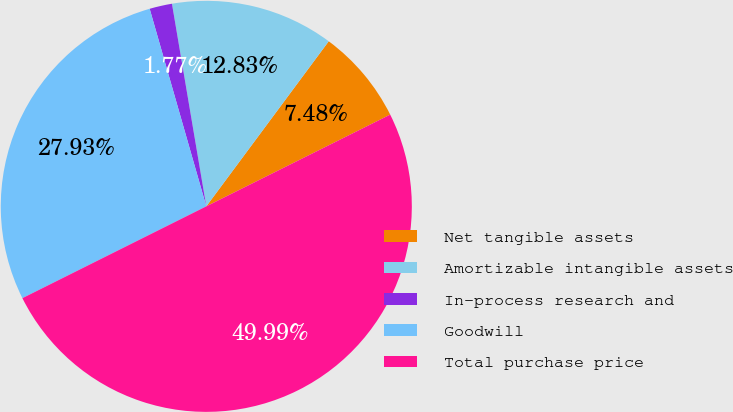Convert chart to OTSL. <chart><loc_0><loc_0><loc_500><loc_500><pie_chart><fcel>Net tangible assets<fcel>Amortizable intangible assets<fcel>In-process research and<fcel>Goodwill<fcel>Total purchase price<nl><fcel>7.48%<fcel>12.83%<fcel>1.77%<fcel>27.93%<fcel>50.0%<nl></chart> 